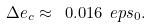<formula> <loc_0><loc_0><loc_500><loc_500>\Delta e _ { c } \approx \ 0 . 0 1 6 \ e p s _ { 0 } .</formula> 